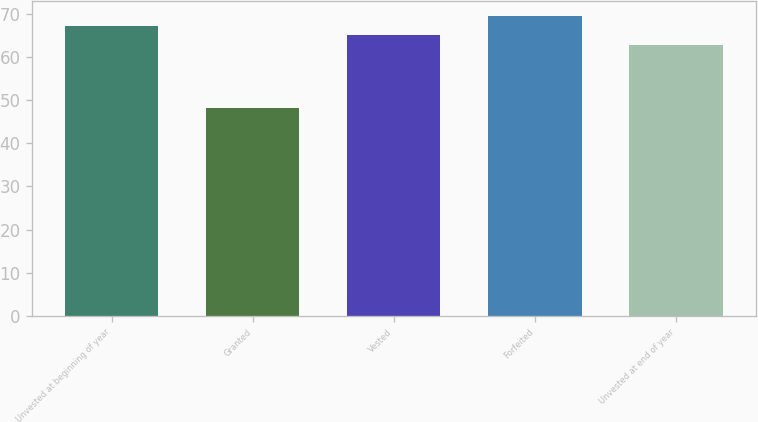Convert chart to OTSL. <chart><loc_0><loc_0><loc_500><loc_500><bar_chart><fcel>Unvested at beginning of year<fcel>Granted<fcel>Vested<fcel>Forfeited<fcel>Unvested at end of year<nl><fcel>67.26<fcel>48.14<fcel>65.15<fcel>69.37<fcel>62.75<nl></chart> 